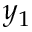Convert formula to latex. <formula><loc_0><loc_0><loc_500><loc_500>y _ { 1 }</formula> 